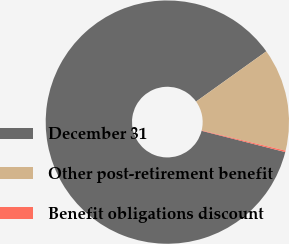Convert chart. <chart><loc_0><loc_0><loc_500><loc_500><pie_chart><fcel>December 31<fcel>Other post-retirement benefit<fcel>Benefit obligations discount<nl><fcel>86.16%<fcel>13.65%<fcel>0.19%<nl></chart> 